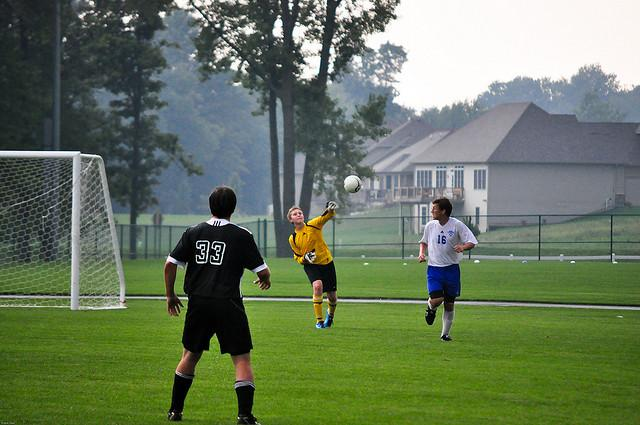Why is the one guy wearing a yellow uniform? Please explain your reasoning. goalie. People are playing soccer and one is in a different uniform from the rest. soccer goalies wear a different shirt from everyone else. 